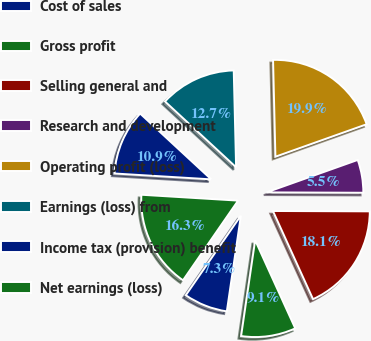<chart> <loc_0><loc_0><loc_500><loc_500><pie_chart><fcel>Cost of sales<fcel>Gross profit<fcel>Selling general and<fcel>Research and development<fcel>Operating profit (loss)<fcel>Earnings (loss) from<fcel>Income tax (provision) benefit<fcel>Net earnings (loss)<nl><fcel>7.31%<fcel>9.11%<fcel>18.15%<fcel>5.5%<fcel>19.95%<fcel>12.73%<fcel>10.92%<fcel>16.34%<nl></chart> 